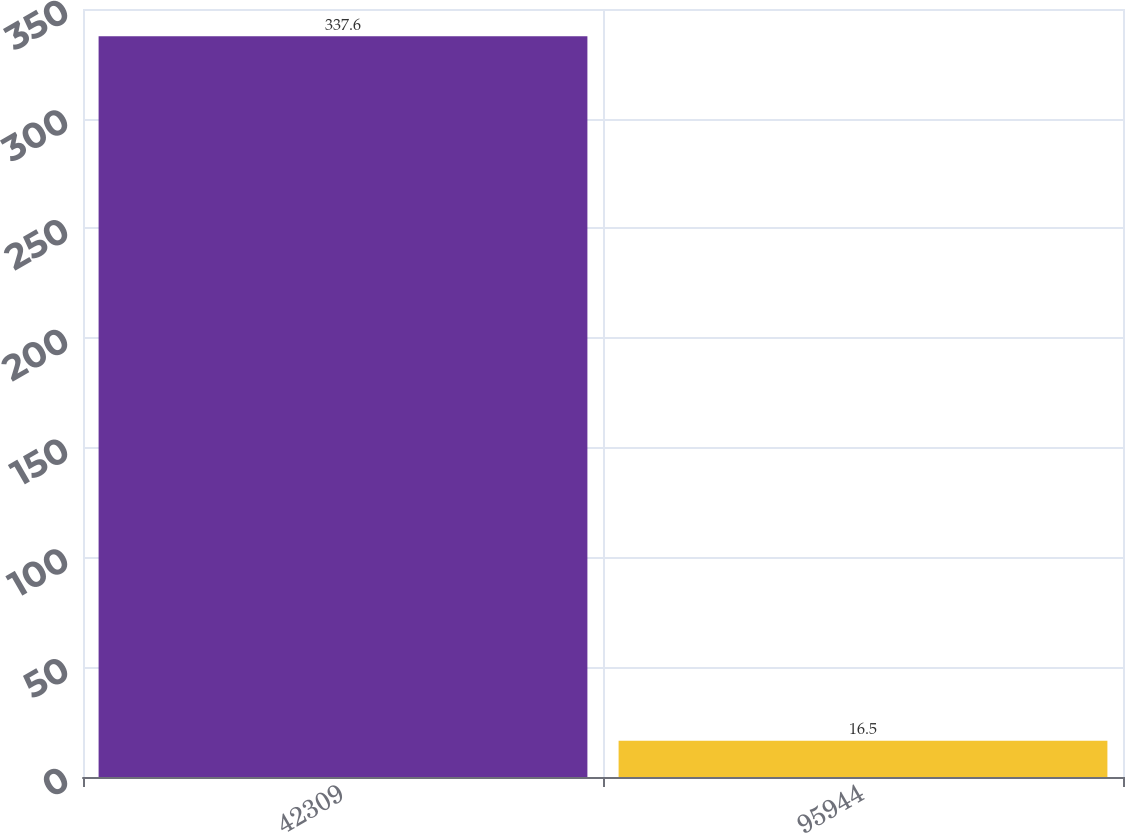<chart> <loc_0><loc_0><loc_500><loc_500><bar_chart><fcel>42309<fcel>95944<nl><fcel>337.6<fcel>16.5<nl></chart> 